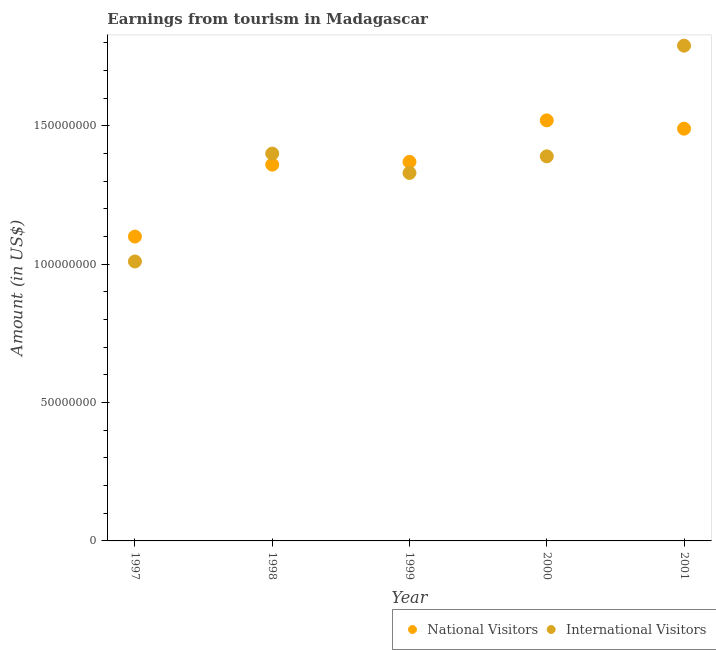What is the amount earned from national visitors in 1998?
Your answer should be very brief. 1.36e+08. Across all years, what is the maximum amount earned from national visitors?
Offer a very short reply. 1.52e+08. Across all years, what is the minimum amount earned from national visitors?
Provide a short and direct response. 1.10e+08. In which year was the amount earned from national visitors minimum?
Offer a very short reply. 1997. What is the total amount earned from national visitors in the graph?
Offer a very short reply. 6.84e+08. What is the difference between the amount earned from national visitors in 1997 and that in 1998?
Provide a succinct answer. -2.60e+07. What is the difference between the amount earned from national visitors in 2001 and the amount earned from international visitors in 1998?
Offer a very short reply. 9.00e+06. What is the average amount earned from international visitors per year?
Provide a succinct answer. 1.38e+08. In the year 1998, what is the difference between the amount earned from international visitors and amount earned from national visitors?
Your answer should be very brief. 4.00e+06. In how many years, is the amount earned from national visitors greater than 90000000 US$?
Provide a short and direct response. 5. What is the ratio of the amount earned from national visitors in 1999 to that in 2000?
Provide a short and direct response. 0.9. Is the difference between the amount earned from international visitors in 1997 and 1998 greater than the difference between the amount earned from national visitors in 1997 and 1998?
Make the answer very short. No. What is the difference between the highest and the second highest amount earned from national visitors?
Offer a very short reply. 3.00e+06. What is the difference between the highest and the lowest amount earned from national visitors?
Provide a short and direct response. 4.20e+07. In how many years, is the amount earned from international visitors greater than the average amount earned from international visitors taken over all years?
Give a very brief answer. 3. Is the sum of the amount earned from national visitors in 2000 and 2001 greater than the maximum amount earned from international visitors across all years?
Make the answer very short. Yes. Is the amount earned from international visitors strictly less than the amount earned from national visitors over the years?
Make the answer very short. No. How many dotlines are there?
Provide a short and direct response. 2. How many years are there in the graph?
Your answer should be compact. 5. What is the difference between two consecutive major ticks on the Y-axis?
Offer a terse response. 5.00e+07. Does the graph contain any zero values?
Provide a succinct answer. No. Where does the legend appear in the graph?
Your answer should be compact. Bottom right. How many legend labels are there?
Offer a very short reply. 2. How are the legend labels stacked?
Your answer should be compact. Horizontal. What is the title of the graph?
Ensure brevity in your answer.  Earnings from tourism in Madagascar. Does "Primary completion rate" appear as one of the legend labels in the graph?
Provide a succinct answer. No. What is the label or title of the Y-axis?
Offer a terse response. Amount (in US$). What is the Amount (in US$) in National Visitors in 1997?
Offer a very short reply. 1.10e+08. What is the Amount (in US$) in International Visitors in 1997?
Your response must be concise. 1.01e+08. What is the Amount (in US$) of National Visitors in 1998?
Your response must be concise. 1.36e+08. What is the Amount (in US$) in International Visitors in 1998?
Offer a terse response. 1.40e+08. What is the Amount (in US$) in National Visitors in 1999?
Provide a succinct answer. 1.37e+08. What is the Amount (in US$) of International Visitors in 1999?
Give a very brief answer. 1.33e+08. What is the Amount (in US$) of National Visitors in 2000?
Make the answer very short. 1.52e+08. What is the Amount (in US$) of International Visitors in 2000?
Your answer should be compact. 1.39e+08. What is the Amount (in US$) of National Visitors in 2001?
Keep it short and to the point. 1.49e+08. What is the Amount (in US$) of International Visitors in 2001?
Offer a very short reply. 1.79e+08. Across all years, what is the maximum Amount (in US$) of National Visitors?
Offer a very short reply. 1.52e+08. Across all years, what is the maximum Amount (in US$) of International Visitors?
Provide a short and direct response. 1.79e+08. Across all years, what is the minimum Amount (in US$) in National Visitors?
Offer a very short reply. 1.10e+08. Across all years, what is the minimum Amount (in US$) in International Visitors?
Make the answer very short. 1.01e+08. What is the total Amount (in US$) in National Visitors in the graph?
Offer a terse response. 6.84e+08. What is the total Amount (in US$) in International Visitors in the graph?
Provide a succinct answer. 6.92e+08. What is the difference between the Amount (in US$) of National Visitors in 1997 and that in 1998?
Provide a short and direct response. -2.60e+07. What is the difference between the Amount (in US$) in International Visitors in 1997 and that in 1998?
Offer a very short reply. -3.90e+07. What is the difference between the Amount (in US$) in National Visitors in 1997 and that in 1999?
Keep it short and to the point. -2.70e+07. What is the difference between the Amount (in US$) of International Visitors in 1997 and that in 1999?
Make the answer very short. -3.20e+07. What is the difference between the Amount (in US$) of National Visitors in 1997 and that in 2000?
Provide a succinct answer. -4.20e+07. What is the difference between the Amount (in US$) of International Visitors in 1997 and that in 2000?
Provide a short and direct response. -3.80e+07. What is the difference between the Amount (in US$) of National Visitors in 1997 and that in 2001?
Your response must be concise. -3.90e+07. What is the difference between the Amount (in US$) of International Visitors in 1997 and that in 2001?
Your answer should be compact. -7.80e+07. What is the difference between the Amount (in US$) in National Visitors in 1998 and that in 1999?
Give a very brief answer. -1.00e+06. What is the difference between the Amount (in US$) in National Visitors in 1998 and that in 2000?
Keep it short and to the point. -1.60e+07. What is the difference between the Amount (in US$) in National Visitors in 1998 and that in 2001?
Provide a short and direct response. -1.30e+07. What is the difference between the Amount (in US$) in International Visitors in 1998 and that in 2001?
Provide a succinct answer. -3.90e+07. What is the difference between the Amount (in US$) of National Visitors in 1999 and that in 2000?
Your response must be concise. -1.50e+07. What is the difference between the Amount (in US$) in International Visitors in 1999 and that in 2000?
Provide a succinct answer. -6.00e+06. What is the difference between the Amount (in US$) of National Visitors in 1999 and that in 2001?
Offer a very short reply. -1.20e+07. What is the difference between the Amount (in US$) of International Visitors in 1999 and that in 2001?
Your response must be concise. -4.60e+07. What is the difference between the Amount (in US$) of International Visitors in 2000 and that in 2001?
Offer a terse response. -4.00e+07. What is the difference between the Amount (in US$) of National Visitors in 1997 and the Amount (in US$) of International Visitors in 1998?
Ensure brevity in your answer.  -3.00e+07. What is the difference between the Amount (in US$) of National Visitors in 1997 and the Amount (in US$) of International Visitors in 1999?
Your answer should be compact. -2.30e+07. What is the difference between the Amount (in US$) in National Visitors in 1997 and the Amount (in US$) in International Visitors in 2000?
Provide a succinct answer. -2.90e+07. What is the difference between the Amount (in US$) of National Visitors in 1997 and the Amount (in US$) of International Visitors in 2001?
Offer a terse response. -6.90e+07. What is the difference between the Amount (in US$) in National Visitors in 1998 and the Amount (in US$) in International Visitors in 1999?
Offer a very short reply. 3.00e+06. What is the difference between the Amount (in US$) in National Visitors in 1998 and the Amount (in US$) in International Visitors in 2000?
Offer a very short reply. -3.00e+06. What is the difference between the Amount (in US$) of National Visitors in 1998 and the Amount (in US$) of International Visitors in 2001?
Provide a short and direct response. -4.30e+07. What is the difference between the Amount (in US$) of National Visitors in 1999 and the Amount (in US$) of International Visitors in 2001?
Provide a short and direct response. -4.20e+07. What is the difference between the Amount (in US$) in National Visitors in 2000 and the Amount (in US$) in International Visitors in 2001?
Make the answer very short. -2.70e+07. What is the average Amount (in US$) of National Visitors per year?
Offer a very short reply. 1.37e+08. What is the average Amount (in US$) in International Visitors per year?
Provide a succinct answer. 1.38e+08. In the year 1997, what is the difference between the Amount (in US$) of National Visitors and Amount (in US$) of International Visitors?
Offer a terse response. 9.00e+06. In the year 1998, what is the difference between the Amount (in US$) of National Visitors and Amount (in US$) of International Visitors?
Your answer should be very brief. -4.00e+06. In the year 1999, what is the difference between the Amount (in US$) in National Visitors and Amount (in US$) in International Visitors?
Offer a very short reply. 4.00e+06. In the year 2000, what is the difference between the Amount (in US$) of National Visitors and Amount (in US$) of International Visitors?
Offer a terse response. 1.30e+07. In the year 2001, what is the difference between the Amount (in US$) in National Visitors and Amount (in US$) in International Visitors?
Provide a short and direct response. -3.00e+07. What is the ratio of the Amount (in US$) in National Visitors in 1997 to that in 1998?
Make the answer very short. 0.81. What is the ratio of the Amount (in US$) of International Visitors in 1997 to that in 1998?
Provide a short and direct response. 0.72. What is the ratio of the Amount (in US$) in National Visitors in 1997 to that in 1999?
Your answer should be compact. 0.8. What is the ratio of the Amount (in US$) in International Visitors in 1997 to that in 1999?
Offer a very short reply. 0.76. What is the ratio of the Amount (in US$) in National Visitors in 1997 to that in 2000?
Provide a succinct answer. 0.72. What is the ratio of the Amount (in US$) of International Visitors in 1997 to that in 2000?
Your answer should be compact. 0.73. What is the ratio of the Amount (in US$) of National Visitors in 1997 to that in 2001?
Your answer should be compact. 0.74. What is the ratio of the Amount (in US$) of International Visitors in 1997 to that in 2001?
Your answer should be very brief. 0.56. What is the ratio of the Amount (in US$) in International Visitors in 1998 to that in 1999?
Provide a succinct answer. 1.05. What is the ratio of the Amount (in US$) of National Visitors in 1998 to that in 2000?
Your answer should be compact. 0.89. What is the ratio of the Amount (in US$) of International Visitors in 1998 to that in 2000?
Make the answer very short. 1.01. What is the ratio of the Amount (in US$) in National Visitors in 1998 to that in 2001?
Your answer should be compact. 0.91. What is the ratio of the Amount (in US$) in International Visitors in 1998 to that in 2001?
Ensure brevity in your answer.  0.78. What is the ratio of the Amount (in US$) in National Visitors in 1999 to that in 2000?
Provide a short and direct response. 0.9. What is the ratio of the Amount (in US$) of International Visitors in 1999 to that in 2000?
Provide a succinct answer. 0.96. What is the ratio of the Amount (in US$) in National Visitors in 1999 to that in 2001?
Ensure brevity in your answer.  0.92. What is the ratio of the Amount (in US$) of International Visitors in 1999 to that in 2001?
Provide a short and direct response. 0.74. What is the ratio of the Amount (in US$) in National Visitors in 2000 to that in 2001?
Offer a very short reply. 1.02. What is the ratio of the Amount (in US$) in International Visitors in 2000 to that in 2001?
Provide a short and direct response. 0.78. What is the difference between the highest and the second highest Amount (in US$) in National Visitors?
Provide a succinct answer. 3.00e+06. What is the difference between the highest and the second highest Amount (in US$) of International Visitors?
Offer a very short reply. 3.90e+07. What is the difference between the highest and the lowest Amount (in US$) in National Visitors?
Your answer should be compact. 4.20e+07. What is the difference between the highest and the lowest Amount (in US$) in International Visitors?
Your answer should be very brief. 7.80e+07. 